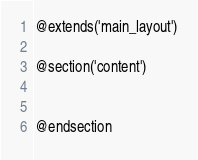Convert code to text. <code><loc_0><loc_0><loc_500><loc_500><_PHP_>@extends('main_layout')

@section('content')


@endsection</code> 